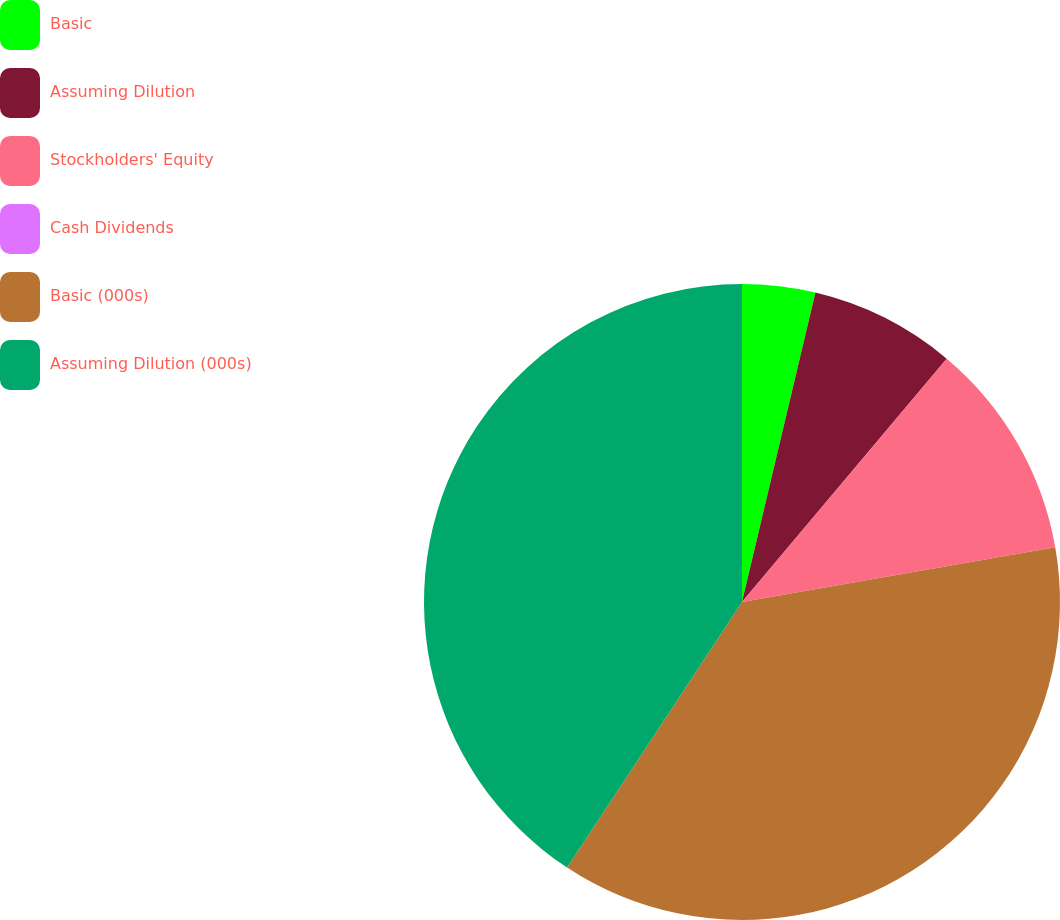<chart> <loc_0><loc_0><loc_500><loc_500><pie_chart><fcel>Basic<fcel>Assuming Dilution<fcel>Stockholders' Equity<fcel>Cash Dividends<fcel>Basic (000s)<fcel>Assuming Dilution (000s)<nl><fcel>3.71%<fcel>7.42%<fcel>11.12%<fcel>0.0%<fcel>37.02%<fcel>40.73%<nl></chart> 